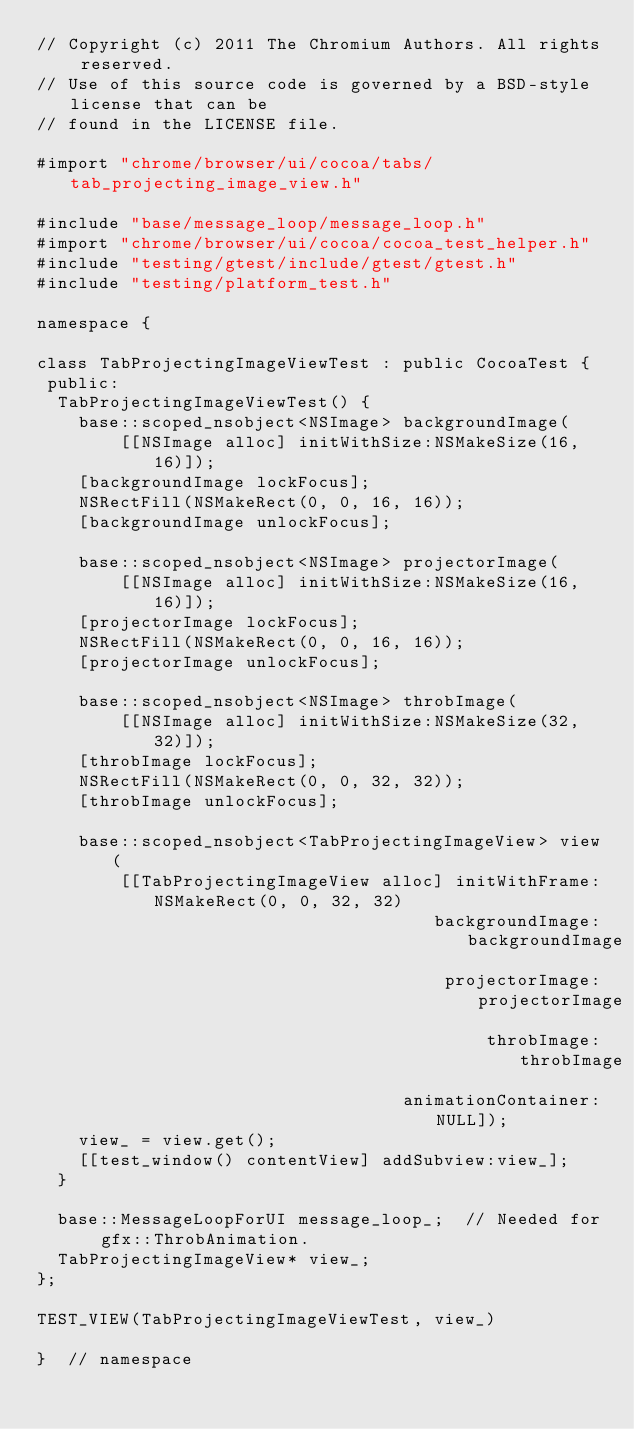Convert code to text. <code><loc_0><loc_0><loc_500><loc_500><_ObjectiveC_>// Copyright (c) 2011 The Chromium Authors. All rights reserved.
// Use of this source code is governed by a BSD-style license that can be
// found in the LICENSE file.

#import "chrome/browser/ui/cocoa/tabs/tab_projecting_image_view.h"

#include "base/message_loop/message_loop.h"
#import "chrome/browser/ui/cocoa/cocoa_test_helper.h"
#include "testing/gtest/include/gtest/gtest.h"
#include "testing/platform_test.h"

namespace {

class TabProjectingImageViewTest : public CocoaTest {
 public:
  TabProjectingImageViewTest() {
    base::scoped_nsobject<NSImage> backgroundImage(
        [[NSImage alloc] initWithSize:NSMakeSize(16, 16)]);
    [backgroundImage lockFocus];
    NSRectFill(NSMakeRect(0, 0, 16, 16));
    [backgroundImage unlockFocus];

    base::scoped_nsobject<NSImage> projectorImage(
        [[NSImage alloc] initWithSize:NSMakeSize(16, 16)]);
    [projectorImage lockFocus];
    NSRectFill(NSMakeRect(0, 0, 16, 16));
    [projectorImage unlockFocus];

    base::scoped_nsobject<NSImage> throbImage(
        [[NSImage alloc] initWithSize:NSMakeSize(32, 32)]);
    [throbImage lockFocus];
    NSRectFill(NSMakeRect(0, 0, 32, 32));
    [throbImage unlockFocus];

    base::scoped_nsobject<TabProjectingImageView> view(
        [[TabProjectingImageView alloc] initWithFrame:NSMakeRect(0, 0, 32, 32)
                                      backgroundImage:backgroundImage
                                       projectorImage:projectorImage
                                           throbImage:throbImage
                                   animationContainer:NULL]);
    view_ = view.get();
    [[test_window() contentView] addSubview:view_];
  }

  base::MessageLoopForUI message_loop_;  // Needed for gfx::ThrobAnimation.
  TabProjectingImageView* view_;
};

TEST_VIEW(TabProjectingImageViewTest, view_)

}  // namespace
</code> 